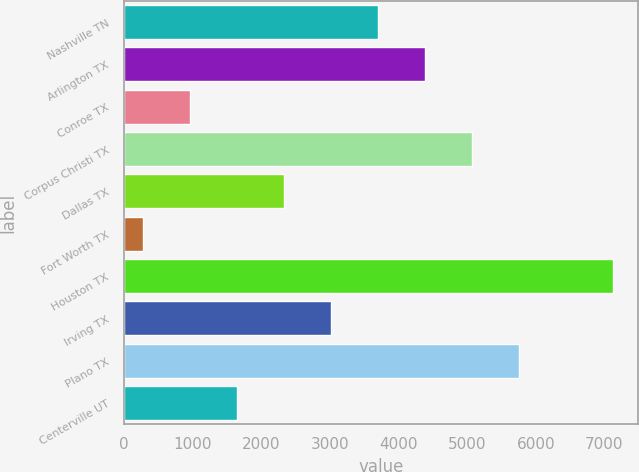Convert chart to OTSL. <chart><loc_0><loc_0><loc_500><loc_500><bar_chart><fcel>Nashville TN<fcel>Arlington TX<fcel>Conroe TX<fcel>Corpus Christi TX<fcel>Dallas TX<fcel>Fort Worth TX<fcel>Houston TX<fcel>Irving TX<fcel>Plano TX<fcel>Centerville UT<nl><fcel>3704.5<fcel>4389.2<fcel>965.7<fcel>5073.9<fcel>2335.1<fcel>281<fcel>7128<fcel>3019.8<fcel>5758.6<fcel>1650.4<nl></chart> 